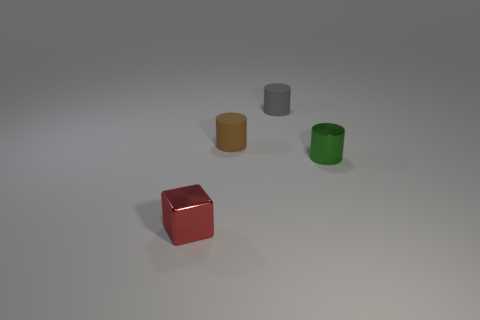Add 1 matte things. How many objects exist? 5 Subtract all cubes. How many objects are left? 3 Subtract all small red matte blocks. Subtract all brown cylinders. How many objects are left? 3 Add 1 tiny cylinders. How many tiny cylinders are left? 4 Add 4 small red cubes. How many small red cubes exist? 5 Subtract 0 green blocks. How many objects are left? 4 